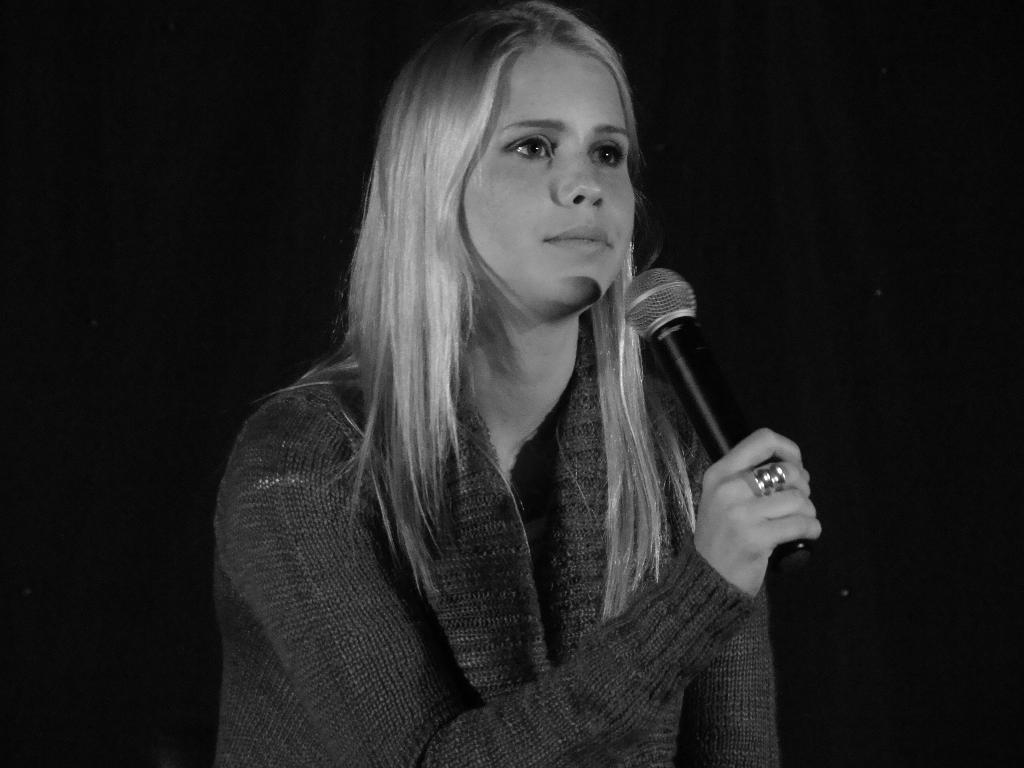What is the main subject of the image? The main subject of the image is a woman. What is the woman doing in the image? The woman is standing and holding a microphone. Can you describe the woman's hair in the image? The woman has white straight hair. What is the color of the background in the image? The background of the image is dark. Can you tell me how many times the woman breathes in the image? It is not possible to determine how many times the woman breathes in the image, as it is a still photograph and does not show the passage of time. Is there a tiger visible in the image? No, there is no tiger present in the image. 